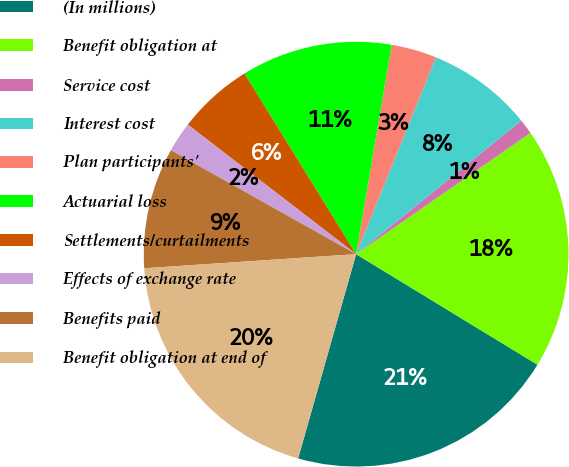<chart> <loc_0><loc_0><loc_500><loc_500><pie_chart><fcel>(In millions)<fcel>Benefit obligation at<fcel>Service cost<fcel>Interest cost<fcel>Plan participants'<fcel>Actuarial loss<fcel>Settlements/curtailments<fcel>Effects of exchange rate<fcel>Benefits paid<fcel>Benefit obligation at end of<nl><fcel>20.69%<fcel>18.39%<fcel>1.15%<fcel>8.05%<fcel>3.45%<fcel>11.49%<fcel>5.75%<fcel>2.3%<fcel>9.2%<fcel>19.54%<nl></chart> 